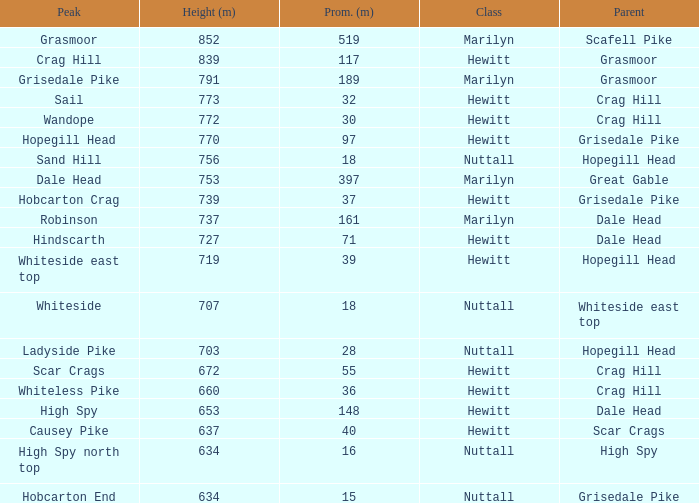Write the full table. {'header': ['Peak', 'Height (m)', 'Prom. (m)', 'Class', 'Parent'], 'rows': [['Grasmoor', '852', '519', 'Marilyn', 'Scafell Pike'], ['Crag Hill', '839', '117', 'Hewitt', 'Grasmoor'], ['Grisedale Pike', '791', '189', 'Marilyn', 'Grasmoor'], ['Sail', '773', '32', 'Hewitt', 'Crag Hill'], ['Wandope', '772', '30', 'Hewitt', 'Crag Hill'], ['Hopegill Head', '770', '97', 'Hewitt', 'Grisedale Pike'], ['Sand Hill', '756', '18', 'Nuttall', 'Hopegill Head'], ['Dale Head', '753', '397', 'Marilyn', 'Great Gable'], ['Hobcarton Crag', '739', '37', 'Hewitt', 'Grisedale Pike'], ['Robinson', '737', '161', 'Marilyn', 'Dale Head'], ['Hindscarth', '727', '71', 'Hewitt', 'Dale Head'], ['Whiteside east top', '719', '39', 'Hewitt', 'Hopegill Head'], ['Whiteside', '707', '18', 'Nuttall', 'Whiteside east top'], ['Ladyside Pike', '703', '28', 'Nuttall', 'Hopegill Head'], ['Scar Crags', '672', '55', 'Hewitt', 'Crag Hill'], ['Whiteless Pike', '660', '36', 'Hewitt', 'Crag Hill'], ['High Spy', '653', '148', 'Hewitt', 'Dale Head'], ['Causey Pike', '637', '40', 'Hewitt', 'Scar Crags'], ['High Spy north top', '634', '16', 'Nuttall', 'High Spy'], ['Hobcarton End', '634', '15', 'Nuttall', 'Grisedale Pike']]} What is the lowest height for Parent grasmoor when it has a Prom larger than 117? 791.0. 